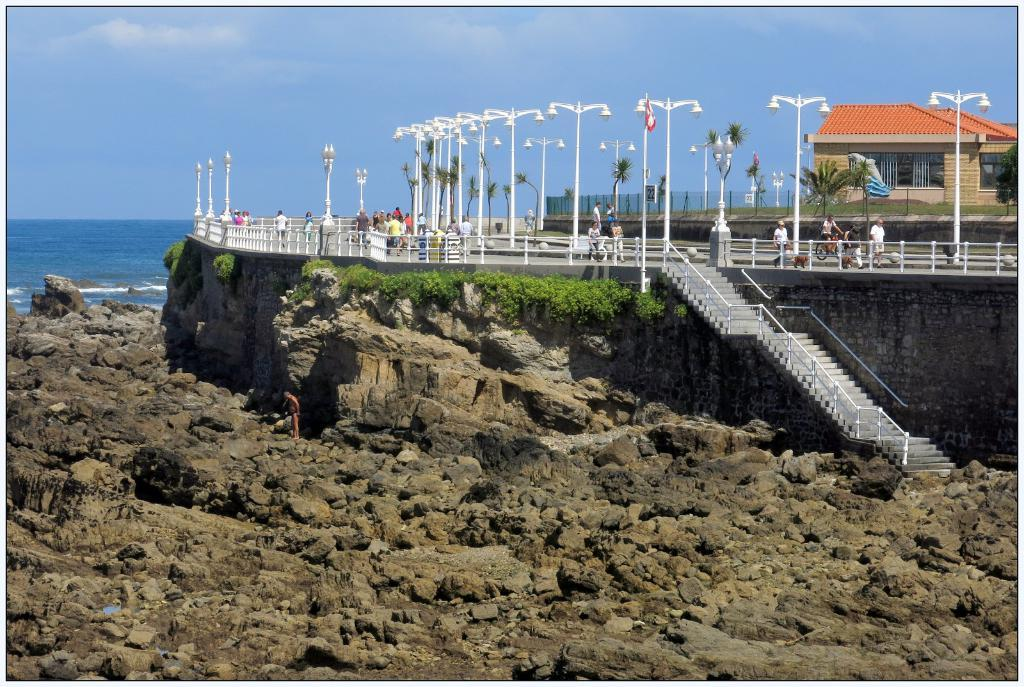What type of natural elements can be seen in the image? There are stones, plants, trees, and water visible in the image. What man-made structures are present in the image? Steps, light poles, fences, a house, and some objects are present in the image. Are there any people in the image? Yes, a group of people is in the image. What is visible in the background of the image? The sky is visible in the background of the image. How many eyes can be seen on the trick apparatus in the image? There is no trick apparatus present in the image, and therefore no eyes can be seen. 